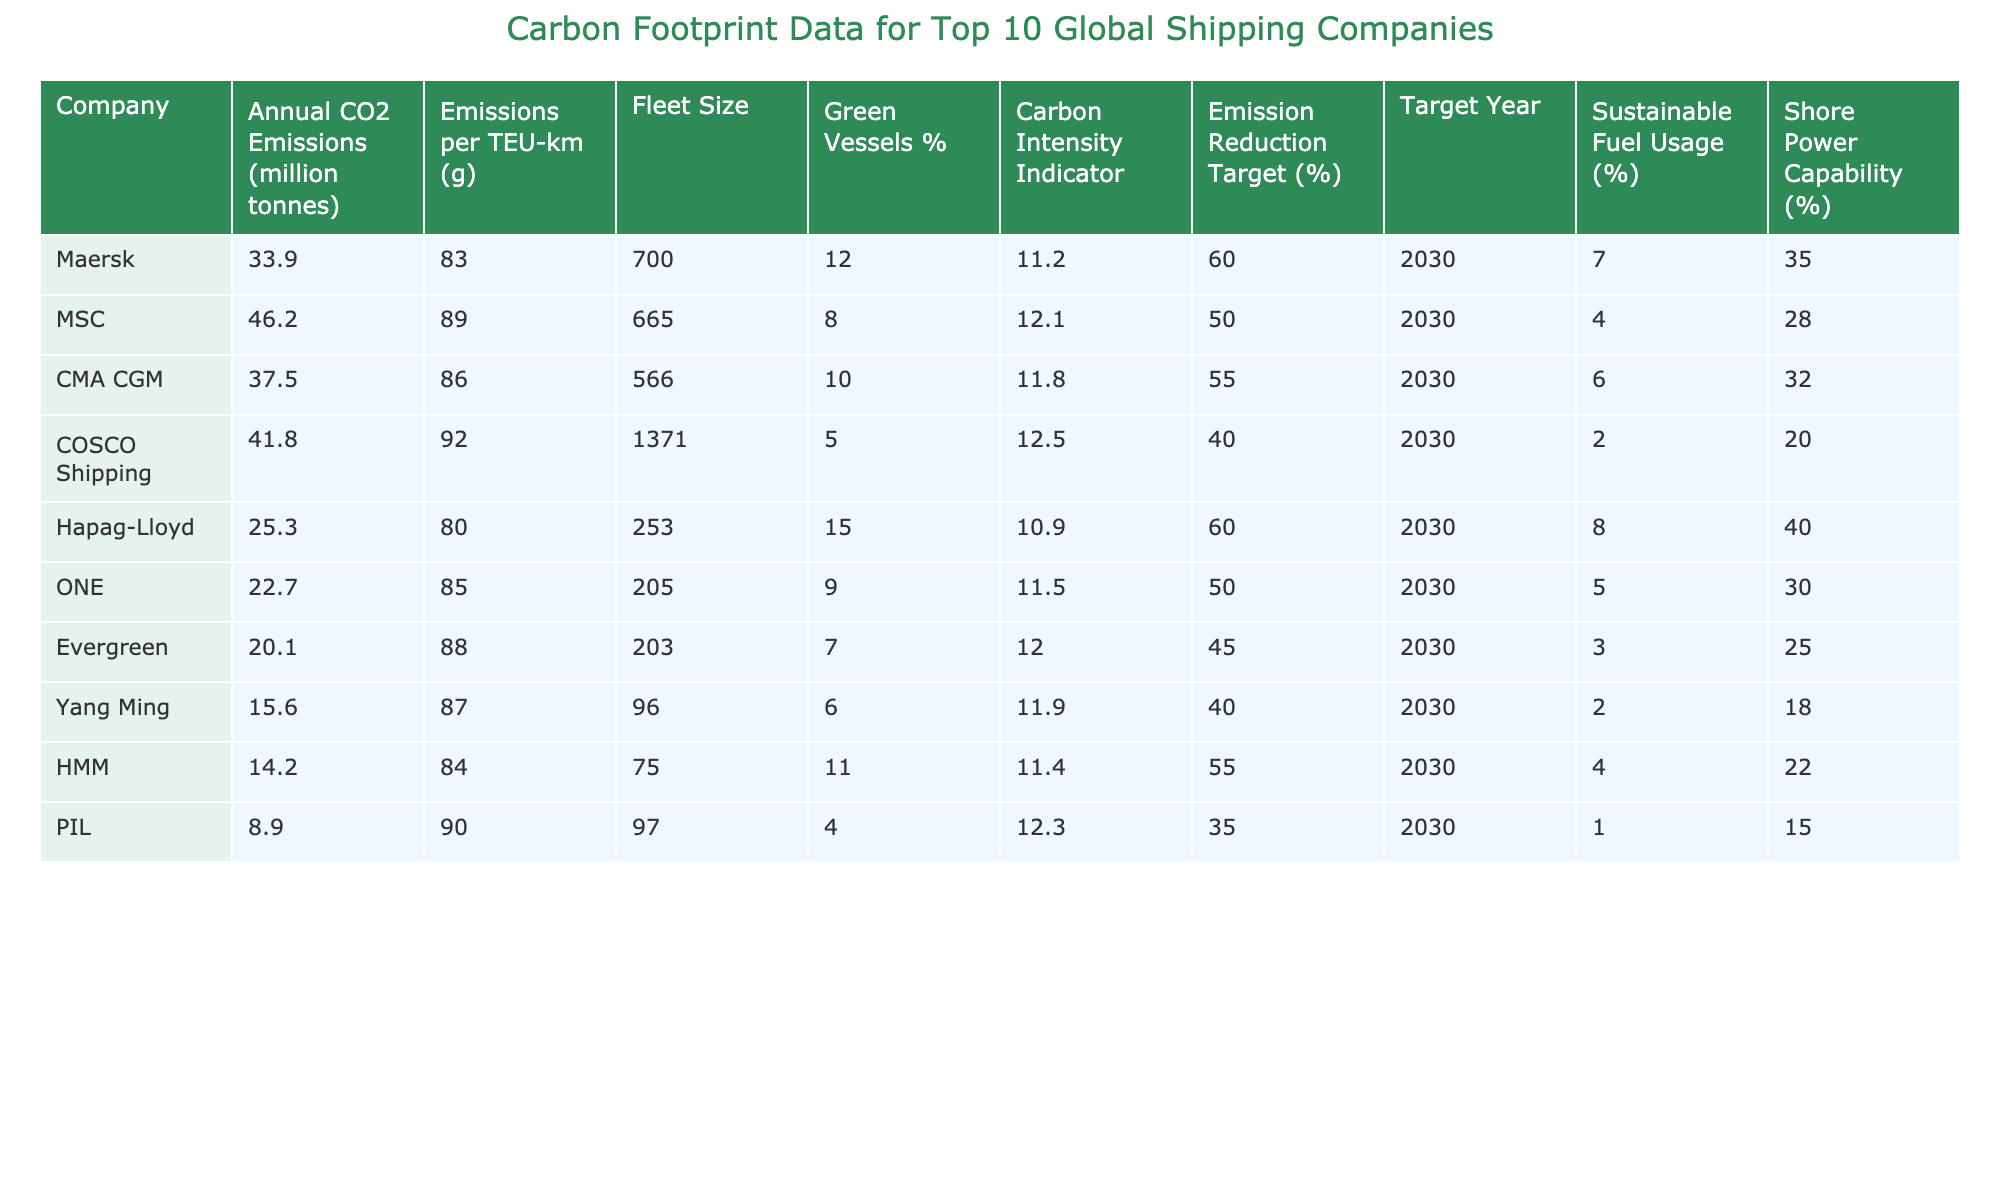What is the carbon footprint of Maersk? The table indicates that Maersk has annual CO2 emissions of 33.9 million tonnes.
Answer: 33.9 million tonnes Which company has the lowest emissions per TEU-km? By looking at the column for emissions per TEU-km, Evergreen has the lowest value at 88 g.
Answer: 88 g How many green vessels does Hapag-Lloyd have? The table shows that Hapag-Lloyd has 15% of its fleet as green vessels.
Answer: 15% What is the emission reduction target for COSCO Shipping? COSCO Shipping aims for an emission reduction target of 40% by the year 2030 as indicated in the table.
Answer: 40% Which company uses the highest percentage of sustainable fuel? Examining the sustainable fuel usage percentage, Maersk leads with 7%.
Answer: 7% What are the average annual CO2 emissions of the top ten companies? To find the average, sum the emissions (33.9 + 46.2 + 37.5 + 41.8 + 25.3 + 22.7 + 20.1 + 15.6 + 14.2 + 8.9 = 314.2) and then divide by 10, giving an average of 31.42 million tonnes.
Answer: 31.42 million tonnes True or False: ONE has a larger fleet size than HMM. Comparing the fleet sizes, ONE has 205 vessels while HMM has 75, which confirms the statement is true.
Answer: True Which company has the highest carbon intensity indicator, and what is its value? The table shows COSCO Shipping has the highest carbon intensity indicator at 12.5.
Answer: 12.5 How do the emissions per TEU-km of MSC compare to those of CMA CGM? Comparing the two companies, MSC's emissions per TEU-km is 89 g, while CMA CGM's is 86 g, meaning MSC has slightly higher emissions.
Answer: MSC has slightly higher emissions What is the difference in the percentage of shore power capability between Evergreen and Yang Ming? Evergreen has 25% shore power capability while Yang Ming has 18%, so the difference is 25 - 18 = 7%.
Answer: 7% What is the total number of green vessels among the top three companies by annual CO2 emissions? Summing up the green vessels percentage, Maersk has 12, MSC has 8, CMA CGM has 10, which totals 30 green vessels among the top three.
Answer: 30 